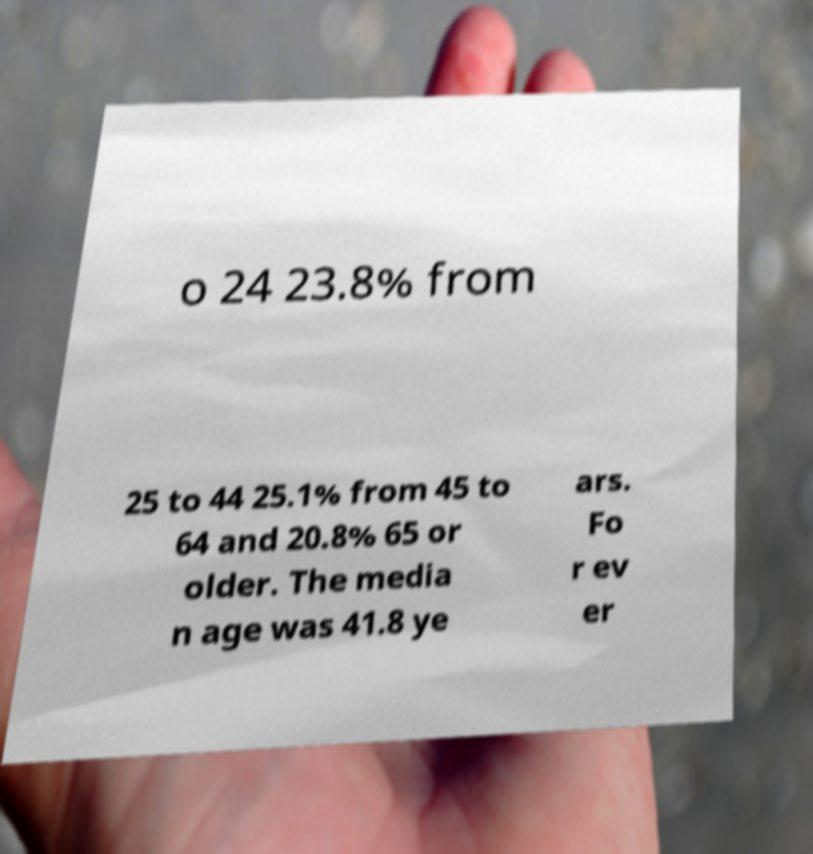There's text embedded in this image that I need extracted. Can you transcribe it verbatim? o 24 23.8% from 25 to 44 25.1% from 45 to 64 and 20.8% 65 or older. The media n age was 41.8 ye ars. Fo r ev er 